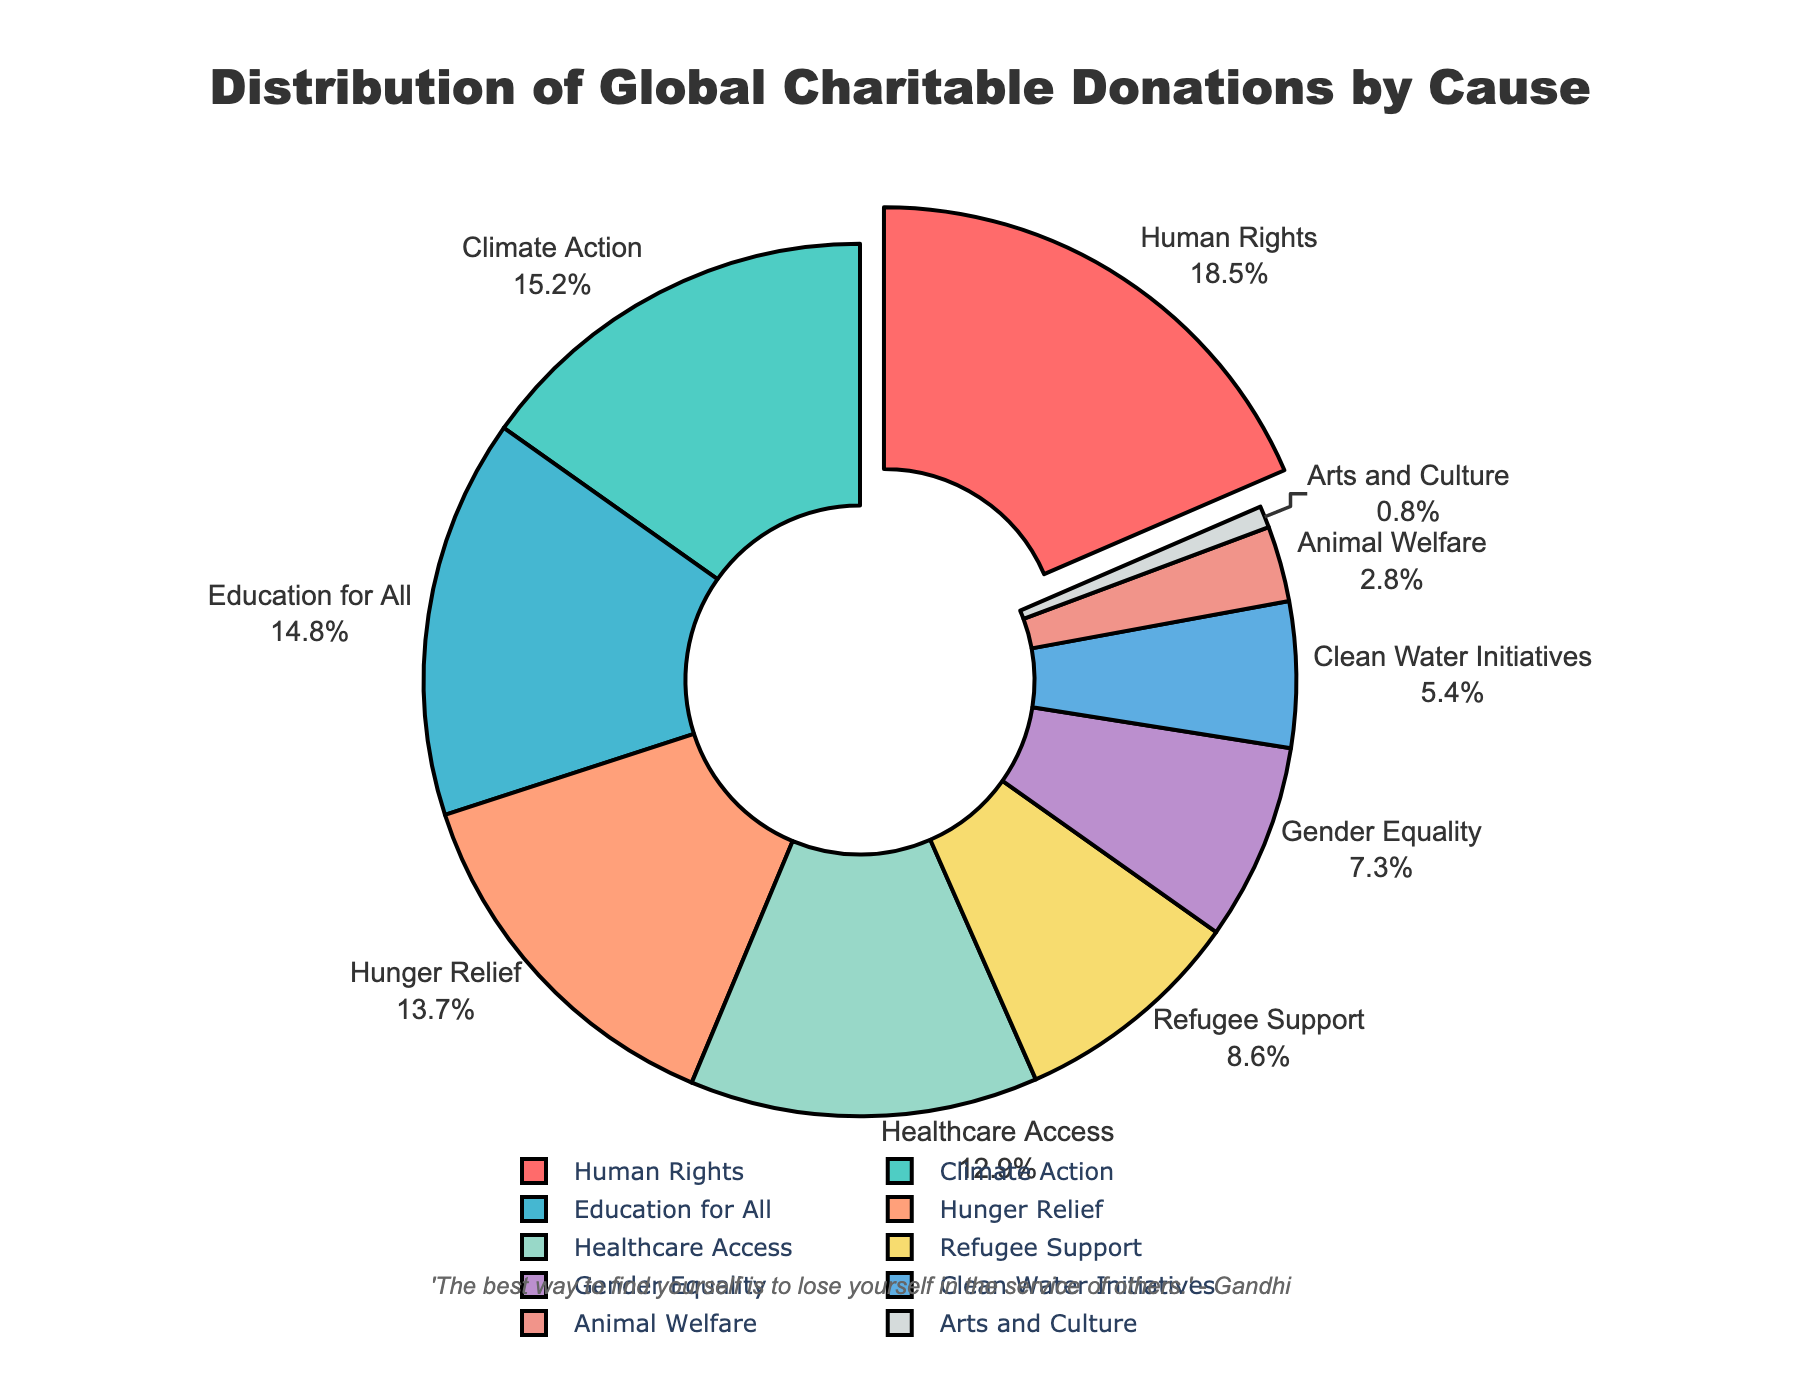What cause receives the largest share of global charitable donations? The figure shows that "Human Rights" has the largest slice of the pie chart and it also has the percentage value next to it, which is 18.5%.
Answer: Human Rights Which causes receive a smaller share of donations than "Healthcare Access"? By looking at the pie chart percentages, "Healthcare Access" receives 12.9%. The causes with a smaller share are "Refugee Support" (8.6%), "Gender Equality" (7.3%), "Clean Water Initiatives" (5.4%), "Animal Welfare" (2.8%), and "Arts and Culture" (0.8%).
Answer: Refugee Support, Gender Equality, Clean Water Initiatives, Animal Welfare, Arts and Culture What is the combined percentage of donations for "Climate Action" and "Education for All"? The percentage for "Climate Action" is 15.2% and for "Education for All" is 14.8%. Adding these together: 15.2% + 14.8% = 30.0%.
Answer: 30.0% How much larger is the donation percentage for "Hunger Relief" compared to "Clean Water Initiatives"? "Hunger Relief" has 13.7% of donations, and "Clean Water Initiatives" has 5.4%. The difference is calculated as 13.7% - 5.4% = 8.3%.
Answer: 8.3% Are there more causes receiving donations above 10% or below 10%? We count the slices above and below 10%. Causes above 10%: "Human Rights", "Climate Action", "Education for All", "Hunger Relief", "Healthcare Access" (5 causes). Causes below 10%: "Refugee Support", "Gender Equality", "Clean Water Initiatives", "Animal Welfare", "Arts and Culture" (5 causes). There are equal numbers of causes receiving donations above and below 10%.
Answer: Equal Which cause is highlighted or pulled out in the pie chart? The visual shows that the slice for "Human Rights" is pulled out from the pie chart, highlighting it.
Answer: Human Rights What percentage share does "Animal Welfare" and "Arts and Culture" combine to? By adding the percentages for "Animal Welfare" (2.8%) and "Arts and Culture" (0.8%), we get a total of 2.8% + 0.8% = 3.6%.
Answer: 3.6% Which cause has the lowest percentage of global charitable donations? The visual shows that "Arts and Culture" has the smallest slice and it has the percentage value of 0.8% next to it.
Answer: Arts and Culture How much more significant is "Gender Equality" compared to "Animal Welfare"? "Gender Equality" receives 7.3% of donations, while "Animal Welfare" receives 2.8%. The difference is calculated as 7.3% - 2.8% = 4.5%.
Answer: 4.5% What is the visual color associated with "Climate Action"? In the pie chart, "Climate Action" has a unique color that is distinguishable. Based on the provided color scheme, it is represented in a light cyan color.
Answer: Light Cyan 